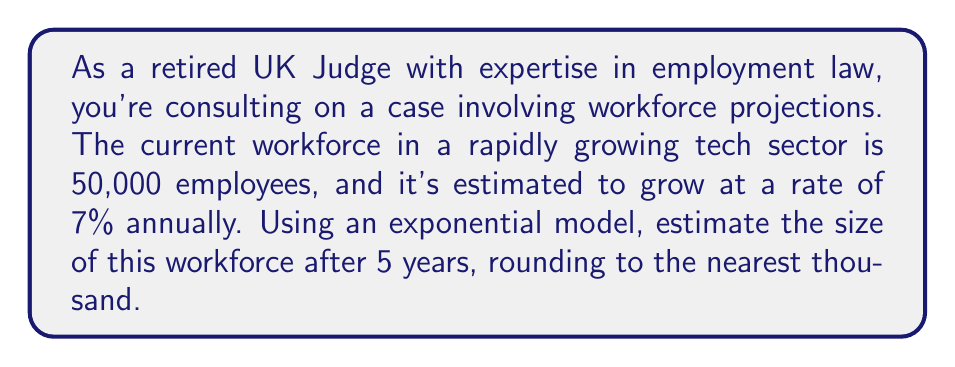Can you solve this math problem? To solve this problem, we'll use the exponential growth formula:

$$A = P(1 + r)^t$$

Where:
$A$ = Final amount
$P$ = Initial population
$r$ = Growth rate (as a decimal)
$t$ = Time period

Given:
$P = 50,000$ (initial workforce)
$r = 0.07$ (7% annual growth rate)
$t = 5$ years

Step 1: Plug the values into the formula
$$A = 50,000(1 + 0.07)^5$$

Step 2: Simplify the expression inside the parentheses
$$A = 50,000(1.07)^5$$

Step 3: Calculate the exponent
$$A = 50,000 \times 1.40255$$

Step 4: Multiply
$$A = 70,127.5$$

Step 5: Round to the nearest thousand
$$A \approx 70,000$$
Answer: 70,000 employees 